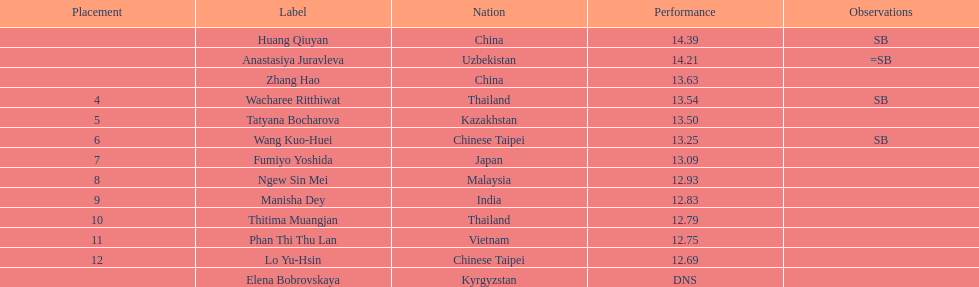Could you help me parse every detail presented in this table? {'header': ['Placement', 'Label', 'Nation', 'Performance', 'Observations'], 'rows': [['', 'Huang Qiuyan', 'China', '14.39', 'SB'], ['', 'Anastasiya Juravleva', 'Uzbekistan', '14.21', '=SB'], ['', 'Zhang Hao', 'China', '13.63', ''], ['4', 'Wacharee Ritthiwat', 'Thailand', '13.54', 'SB'], ['5', 'Tatyana Bocharova', 'Kazakhstan', '13.50', ''], ['6', 'Wang Kuo-Huei', 'Chinese Taipei', '13.25', 'SB'], ['7', 'Fumiyo Yoshida', 'Japan', '13.09', ''], ['8', 'Ngew Sin Mei', 'Malaysia', '12.93', ''], ['9', 'Manisha Dey', 'India', '12.83', ''], ['10', 'Thitima Muangjan', 'Thailand', '12.79', ''], ['11', 'Phan Thi Thu Lan', 'Vietnam', '12.75', ''], ['12', 'Lo Yu-Hsin', 'Chinese Taipei', '12.69', ''], ['', 'Elena Bobrovskaya', 'Kyrgyzstan', 'DNS', '']]} What nationality was the woman who won first place? China. 